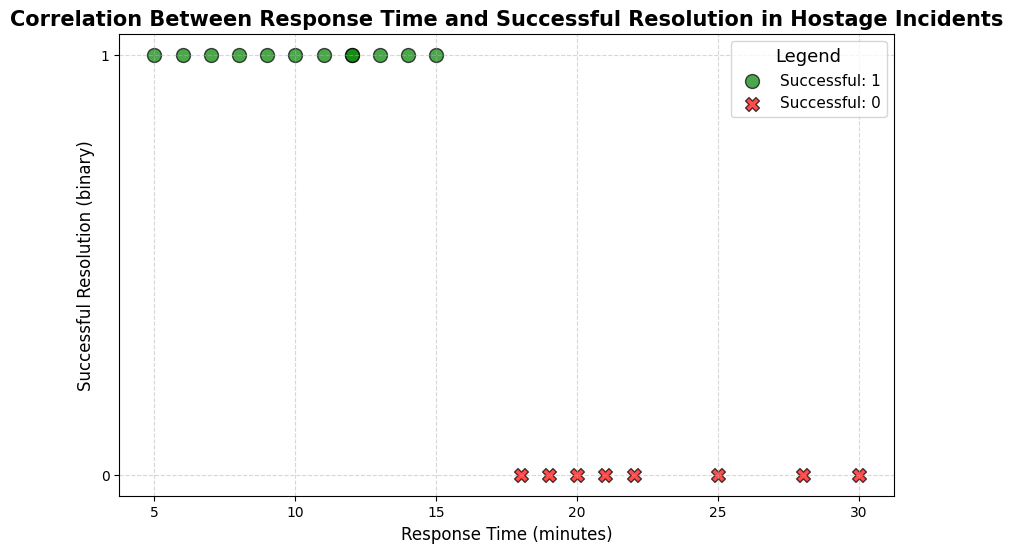What is the overall trend between response time and the successful resolution of hostage incidents? By observing the scatter plot, successful resolutions (green circles) mostly occur at lower response times, whereas unsuccessful resolutions (red Xs) are more frequent at higher response times. This indicates that quicker response times seem to be correlated with more successful resolutions.
Answer: Lower response times correlate with more successful resolutions What are the response times for incidents that had a successful resolution? Look at the green circles in the plot. The response times where resolutions were successful are 5, 12, 8, 12, 6, 9, 14, 7, 11, 13 minutes.
Answer: 5, 12, 8, 12, 6, 9, 14, 7, 11, 13 What is the highest response time for a successful resolution? Among the green circles indicating successful resolutions, the response times are 5, 12, 8, 12, 6, 9, 14, 7, 11, 13 minutes. The highest value in this set is 14 minutes.
Answer: 14 minutes Compare the density of successful resolutions at lower response times (less than 10 minutes) and higher response times (more than 20 minutes). Observing the scatter plot, successful resolutions (green circles) appear denser below 10 minutes compared to other time ranges. Conversely, there are no green circles (indicating successful resolutions) at response times more than 20 minutes.
Answer: Higher density below 10 minutes; none above 20 minutes Which response time has the most occurrences of successful resolutions? Response time of 12 minutes has two green circles indicating successful resolutions, which is the highest frequency for any single response time.
Answer: 12 minutes What can be inferred about the response times of unsuccessful resolutions? Unsuccessful resolutions (red X's) are generally seen at higher response times. The response times for unsuccessful resolutions are 20, 30, 25, 22, 28, 21, 19, and 18 minutes.
Answer: Higher response times Which color represents a successful resolution, and what does this imply about their frequency in relation to unsuccessful resolutions' color? The green color represents a successful resolution. Since the plot shows a higher frequency of green circles at lower response times compared to red Xs at higher response times, successful resolutions are more frequent when response times are shorter.
Answer: Green; more frequent at shorter response times Calculate the average response time for successful resolutions. The response times for successful resolutions are 5, 12, 8, 12, 6, 9, 14, 7, 11, and 13 minutes. Adding these gives a total of 97. Dividing by the 10 occurrences gives an average of 97/10 = 9.7 minutes.
Answer: 9.7 minutes What visual attributes distinguish successful resolutions from unsuccessful resolutions? In the scatter plot, successful resolutions are represented by green circles, while unsuccessful resolutions are represented by red Xs. The shapes (circle vs. X) and colors (green vs. red) visually distinguish them.
Answer: Green circles indicate success; red Xs indicate failure 